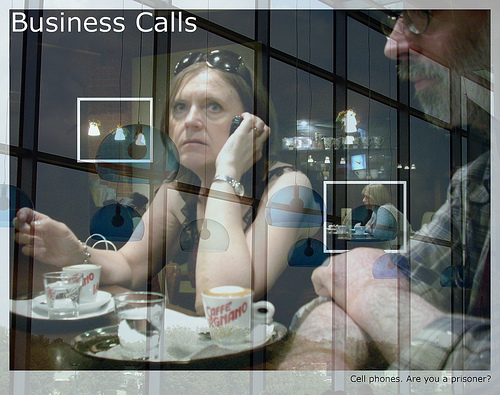What is sitting on top of the plate? The coffee cup is situated on top of the plate. 